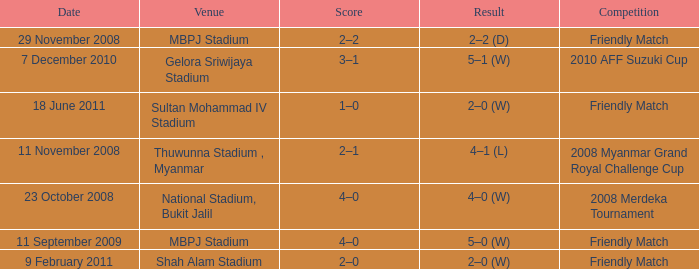What was the Score in Gelora Sriwijaya Stadium? 3–1. 